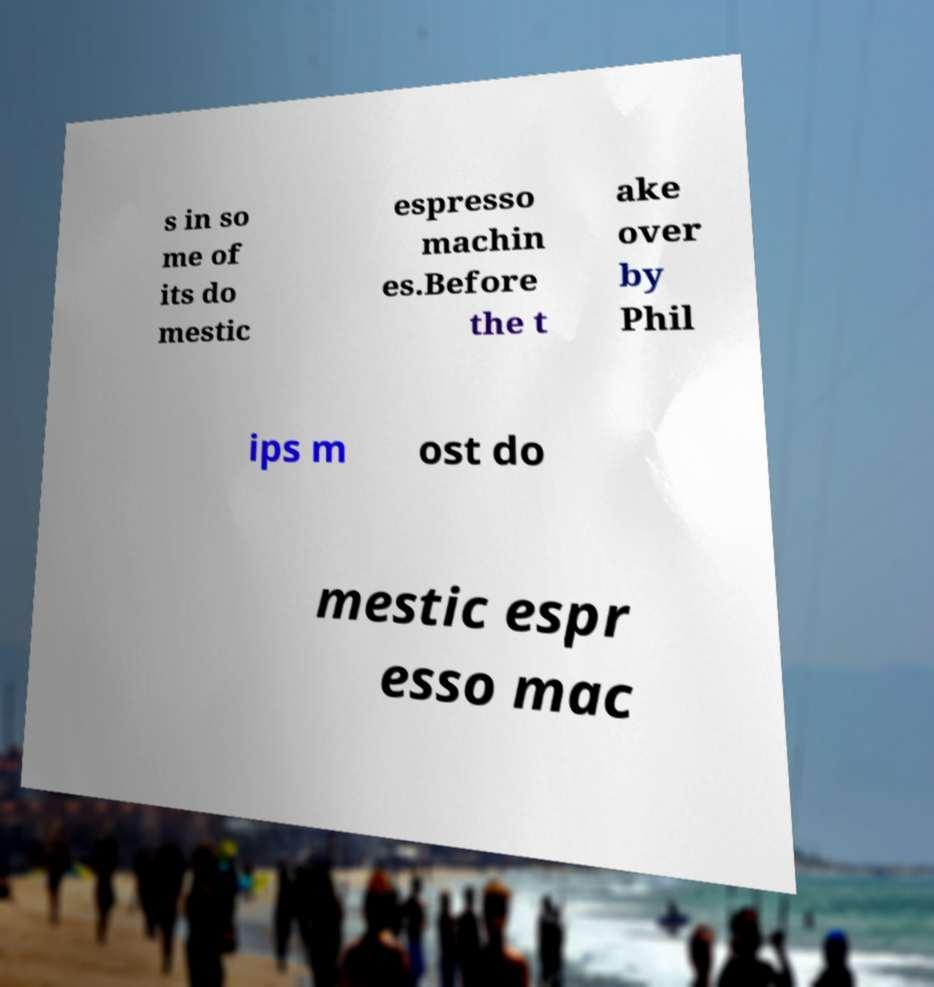Can you accurately transcribe the text from the provided image for me? s in so me of its do mestic espresso machin es.Before the t ake over by Phil ips m ost do mestic espr esso mac 